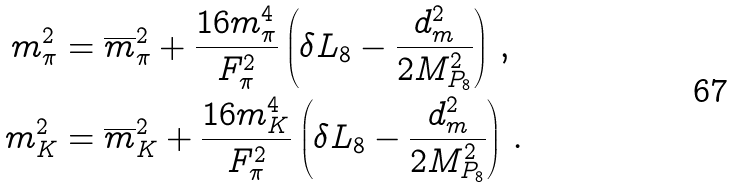<formula> <loc_0><loc_0><loc_500><loc_500>m _ { \pi } ^ { 2 } & = \overline { m } _ { \pi } ^ { 2 } + \frac { 1 6 m _ { \pi } ^ { 4 } } { F _ { \pi } ^ { 2 } } \left ( \delta L _ { 8 } - \frac { d _ { m } ^ { 2 } } { 2 M _ { P _ { 8 } } ^ { 2 } } \right ) \, , \\ m _ { K } ^ { 2 } & = \overline { m } _ { K } ^ { 2 } + \frac { 1 6 m _ { K } ^ { 4 } } { F _ { \pi } ^ { 2 } } \left ( \delta L _ { 8 } - \frac { d _ { m } ^ { 2 } } { 2 M _ { P _ { 8 } } ^ { 2 } } \right ) \, .</formula> 